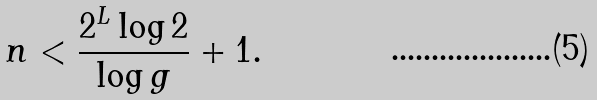<formula> <loc_0><loc_0><loc_500><loc_500>n < \frac { 2 ^ { L } \log 2 } { \log g } + 1 .</formula> 